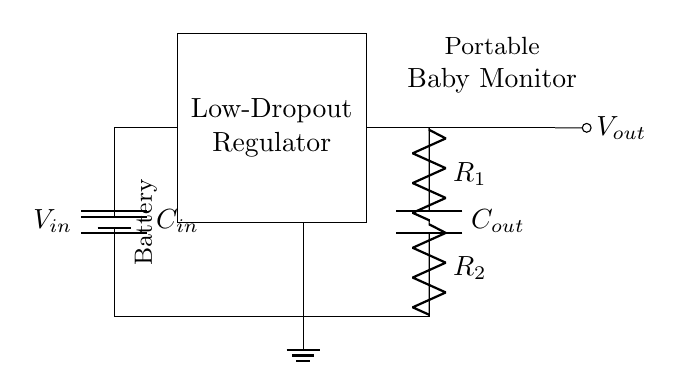What is the type of regulator shown in the diagram? The diagram shows a Low-Dropout Regulator, which is characterized by its ability to maintain the output voltage close to the input voltage, even when the input voltage is slightly higher.
Answer: Low-Dropout Regulator What is the value of the input capacitor labeled as in the circuit? The input capacitor is labeled as C sub in, indicating it is the capacitance connected to the input of the regulator to stabilize the voltage.
Answer: C sub in How many resistors are present in the feedback network? The circuit diagram features two resistors, labeled as R sub 1 and R sub 2, forming a feedback network that is used to set the output voltage of the regulator.
Answer: Two What is the function of the output capacitor in this circuit? The output capacitor is used to improve the transient response and stability of the voltage regulator by smoothing out voltage fluctuations at the output.
Answer: Smoothing voltage fluctuations What does the ground symbol represent in this circuit? The ground symbol indicates the reference point in the circuit, providing a common return path for the current and establishing a zero voltage level in this electrical system.
Answer: Zero voltage level What would happen to the output voltage if the input voltage drops significantly? If the input voltage drops significantly below a certain threshold, the output voltage may also drop below the required level, leading to improper functioning of the baby monitor.
Answer: Output voltage may drop What does the output labeled as V sub out represent? The output labeled V sub out represents the regulated voltage that is supplied to the portable baby monitor, ensuring it operates efficiently within a specified voltage range.
Answer: Regulated voltage for the monitor 